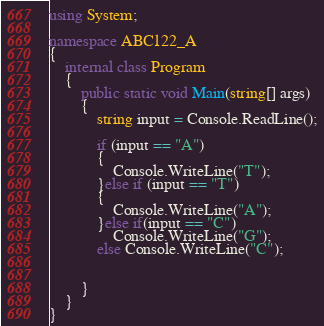<code> <loc_0><loc_0><loc_500><loc_500><_C#_>using System;

namespace ABC122_A
{
	internal class Program
	{
		public static void Main(string[] args)
		{
			string input = Console.ReadLine();

			if (input == "A")
			{
				Console.WriteLine("T");
			}else if (input == "T")
			{
				Console.WriteLine("A");
			}else if(input == "C")
				Console.WriteLine("G");
			else Console.WriteLine("C");
				
			
		}
	}
}</code> 